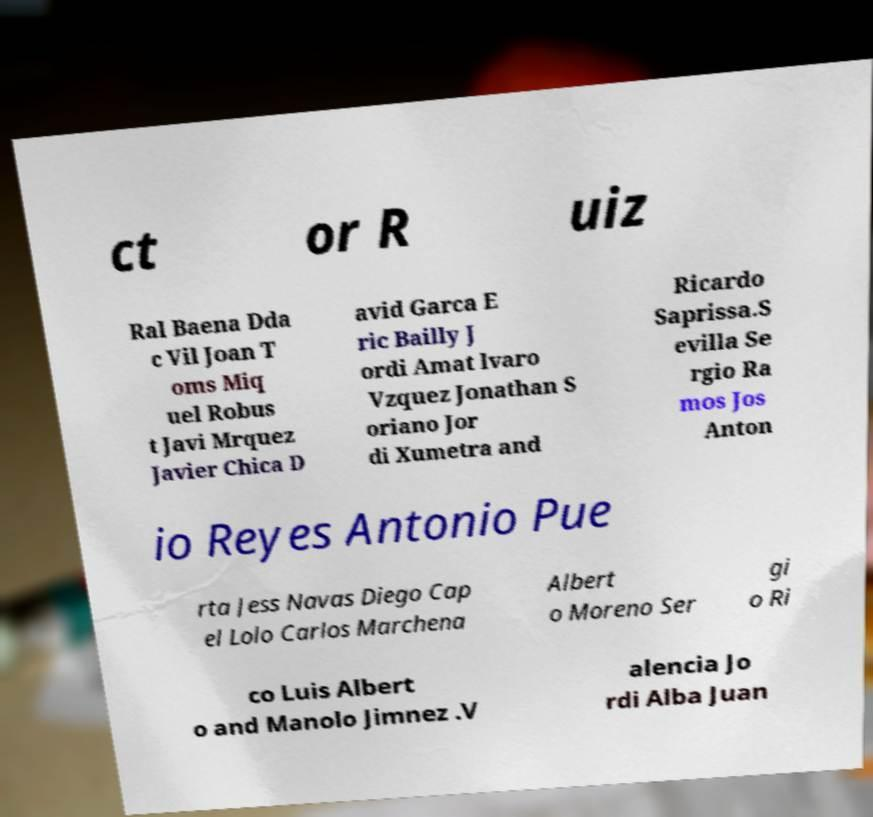Can you read and provide the text displayed in the image?This photo seems to have some interesting text. Can you extract and type it out for me? ct or R uiz Ral Baena Dda c Vil Joan T oms Miq uel Robus t Javi Mrquez Javier Chica D avid Garca E ric Bailly J ordi Amat lvaro Vzquez Jonathan S oriano Jor di Xumetra and Ricardo Saprissa.S evilla Se rgio Ra mos Jos Anton io Reyes Antonio Pue rta Jess Navas Diego Cap el Lolo Carlos Marchena Albert o Moreno Ser gi o Ri co Luis Albert o and Manolo Jimnez .V alencia Jo rdi Alba Juan 